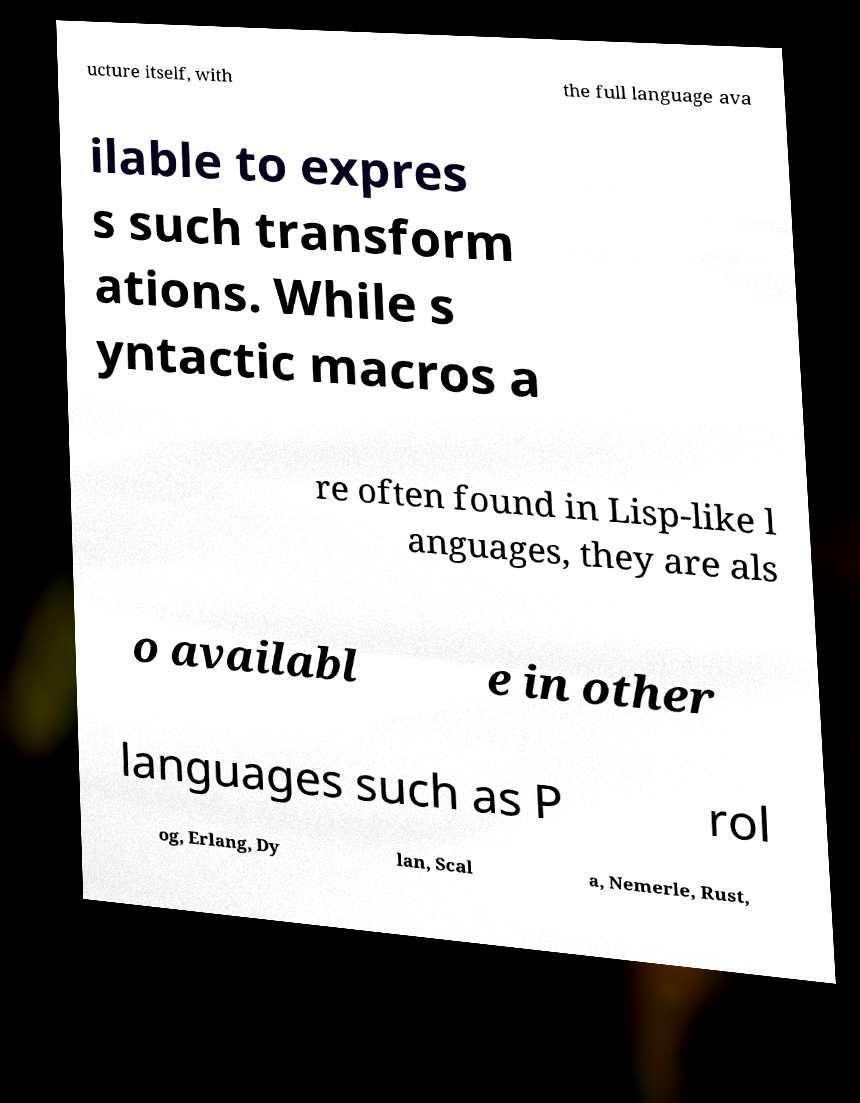Could you extract and type out the text from this image? ucture itself, with the full language ava ilable to expres s such transform ations. While s yntactic macros a re often found in Lisp-like l anguages, they are als o availabl e in other languages such as P rol og, Erlang, Dy lan, Scal a, Nemerle, Rust, 